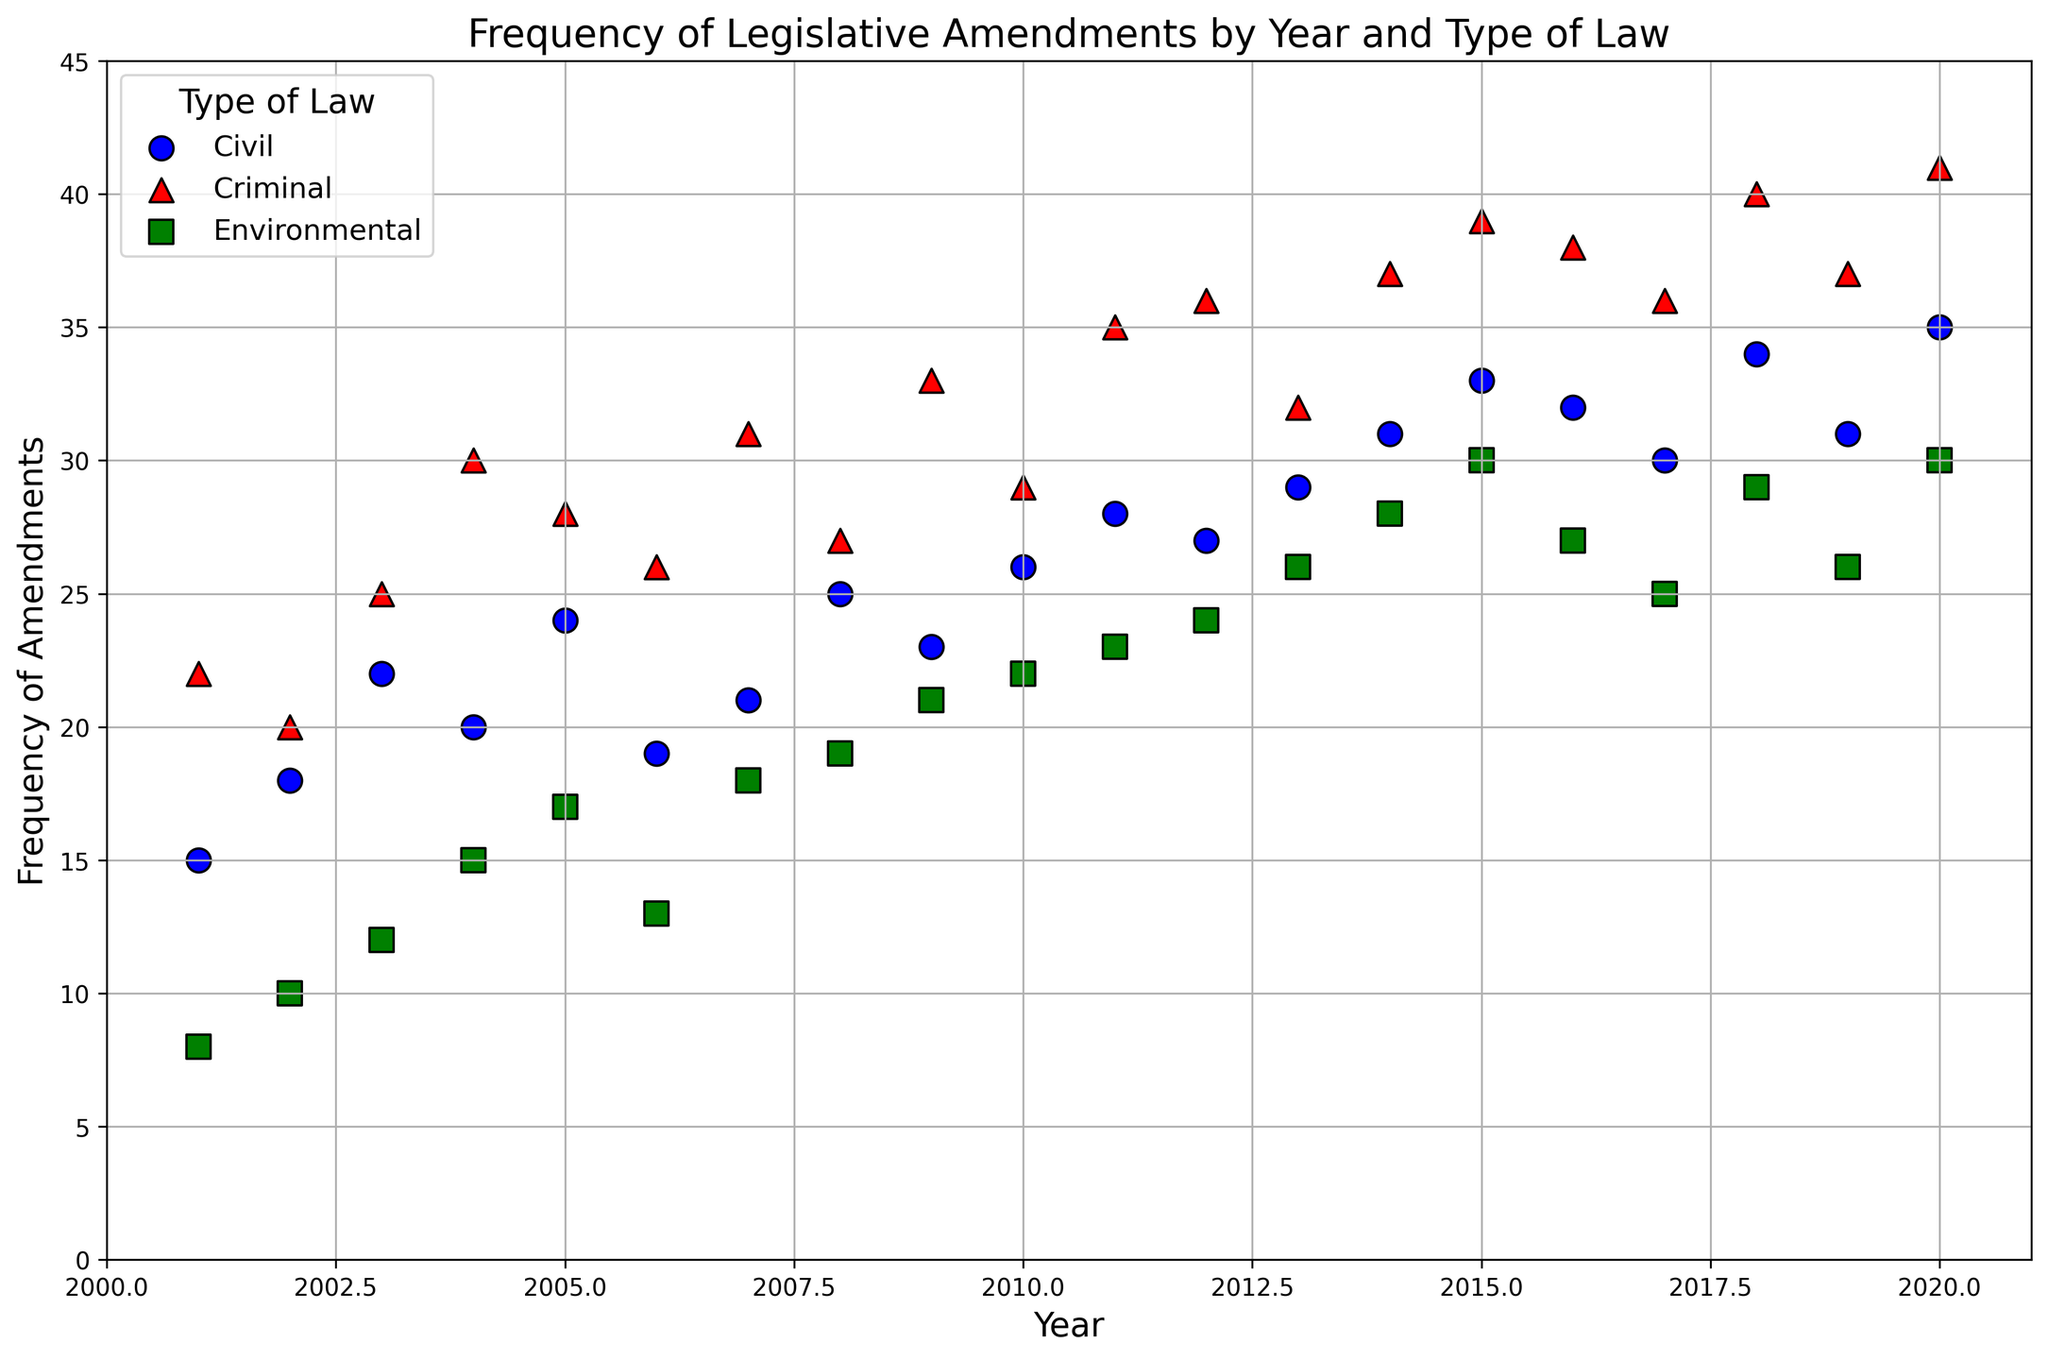What's the trend in the frequency of amendments for Criminal law from 2001 to 2020? To answer this, look at the red markers on the plot. Notice that the frequency of amendments for Criminal law increases almost every year from 22 in 2001 to 41 in 2020.
Answer: Increasing trend Which year had the highest frequency of amendments for Environmental law? By examining the green markers, the highest frequency of amendments for Environmental law is in 2020 with a frequency of 30.
Answer: 2020 In which year did Civil law see the highest number of amendments? The blue markers show the trends for Civil law. The peak value is in 2020 with a frequency of 35 amendments.
Answer: 2020 Comparing the frequencies in 2008, which type of law had the highest number of amendments? Look at the markers for the year 2008. Criminal law has the highest frequency with 27, compared to 25 for Civil law and 19 for Environmental law.
Answer: Criminal law How many more amendments did Criminal law have compared to Environmental law in 2015? Check the values for 2015. Criminal law had 39 amendments, and Environmental law had 30. Subtract the values: 39 - 30 = 9.
Answer: 9 What is the average frequency of amendments for Civil law over the entire period? Sum all the amendments for Civil law from 2001 to 2020: (15 + 18 + 22 + 20 + 24 + 19 + 21 + 25 + 23 + 26 + 28 + 27 + 29 + 31 + 33 + 32 + 30 + 34 + 31 + 35) = 483. Divide by the number of years (20): 483 / 20 = 24.15.
Answer: 24.15 During which year did all three law types have an identical trend in an increase of amendments from the previous year? Check for years where all three types had an increase. From 2014 to 2015, Civil law increased from 31 to 33, Criminal law from 37 to 39, and Environmental law from 28 to 30, all showing an increase.
Answer: 2014 to 2015 How much did the frequency of amendments for Environmental law change from 2007 to 2008? The frequency in 2007 was 18, and in 2008, it was 19. The change is 19 - 18 = 1.
Answer: 1 Compare Civil and Environmental law: which had a more consistent increase in frequency of amendments over 2001 to 2020? Evaluate the smoothness of the trends. Civil law shows a more gradual and consistent increase, while Environmental law shows more fluctuations.
Answer: Civil law 